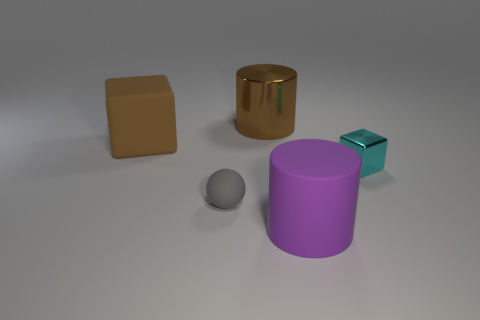Add 4 matte things. How many objects exist? 9 Subtract all balls. How many objects are left? 4 Subtract all brown balls. How many brown blocks are left? 1 Subtract all blue cubes. Subtract all yellow spheres. How many cubes are left? 2 Subtract all small cyan shiny things. Subtract all tiny cubes. How many objects are left? 3 Add 2 brown cylinders. How many brown cylinders are left? 3 Add 2 large purple things. How many large purple things exist? 3 Subtract 0 red cubes. How many objects are left? 5 